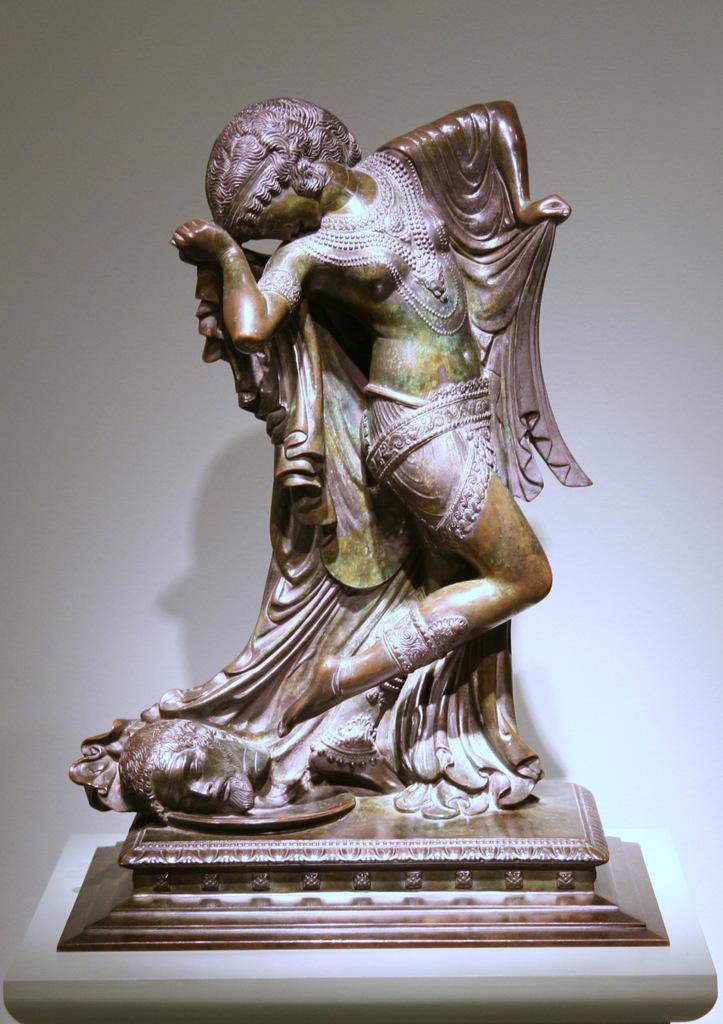Can you describe this image briefly? Here in this picture we can see an art statue present on the table over there. 